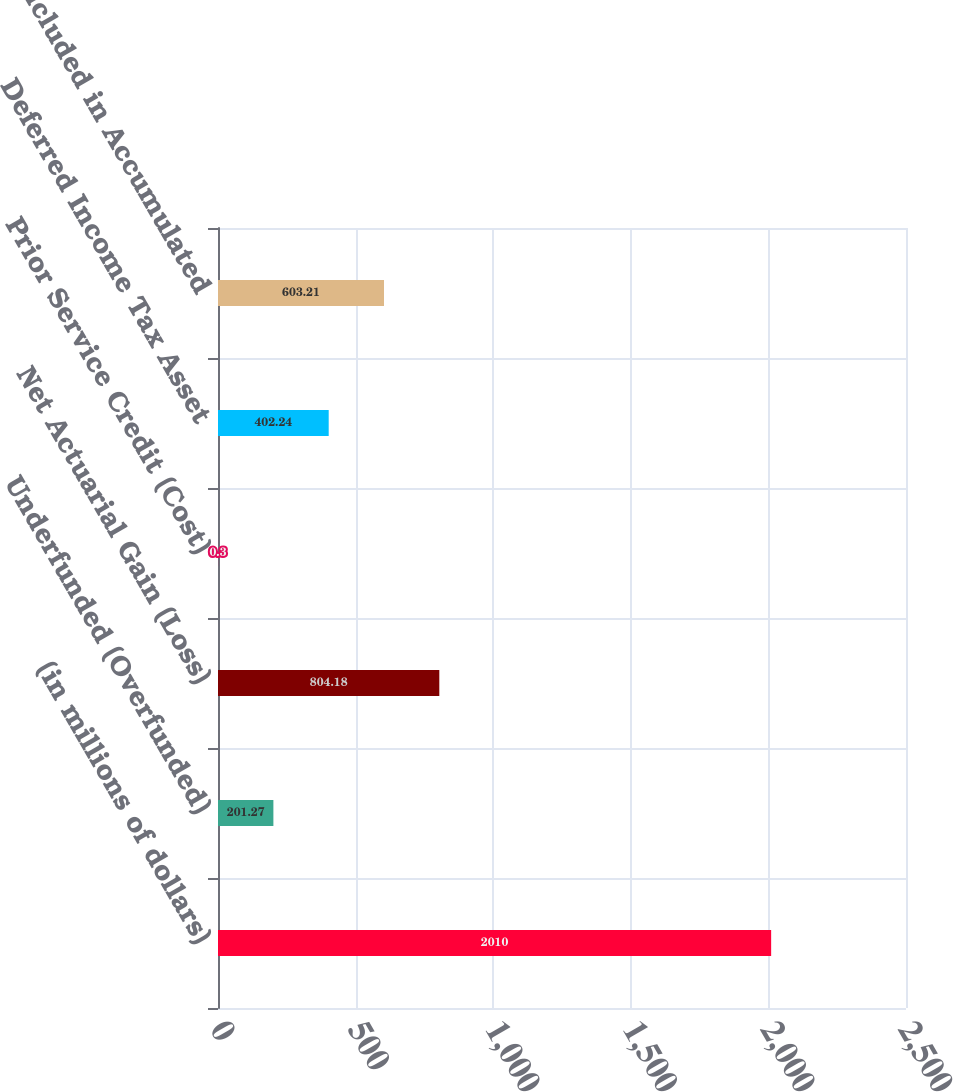Convert chart. <chart><loc_0><loc_0><loc_500><loc_500><bar_chart><fcel>(in millions of dollars)<fcel>Underfunded (Overfunded)<fcel>Net Actuarial Gain (Loss)<fcel>Prior Service Credit (Cost)<fcel>Deferred Income Tax Asset<fcel>Total Included in Accumulated<nl><fcel>2010<fcel>201.27<fcel>804.18<fcel>0.3<fcel>402.24<fcel>603.21<nl></chart> 